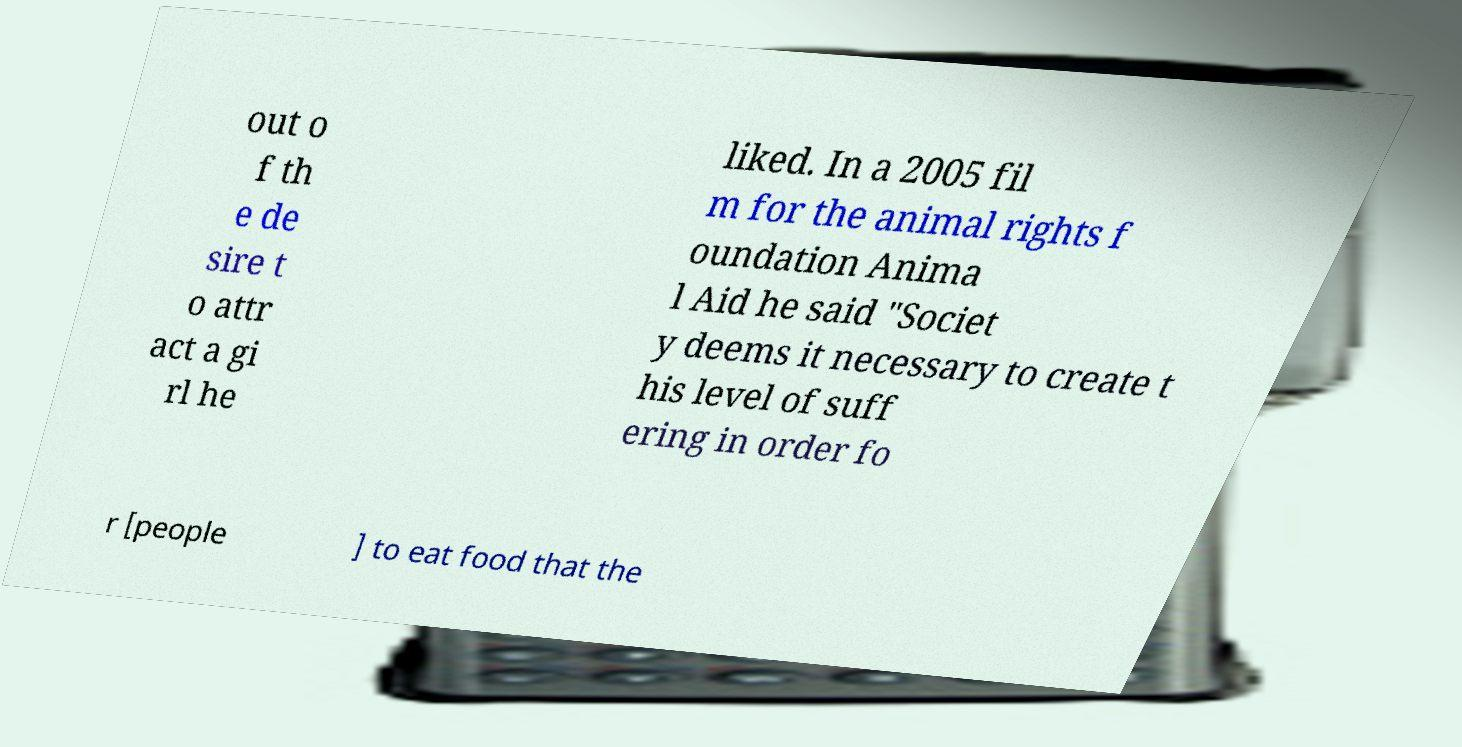Could you extract and type out the text from this image? out o f th e de sire t o attr act a gi rl he liked. In a 2005 fil m for the animal rights f oundation Anima l Aid he said "Societ y deems it necessary to create t his level of suff ering in order fo r [people ] to eat food that the 